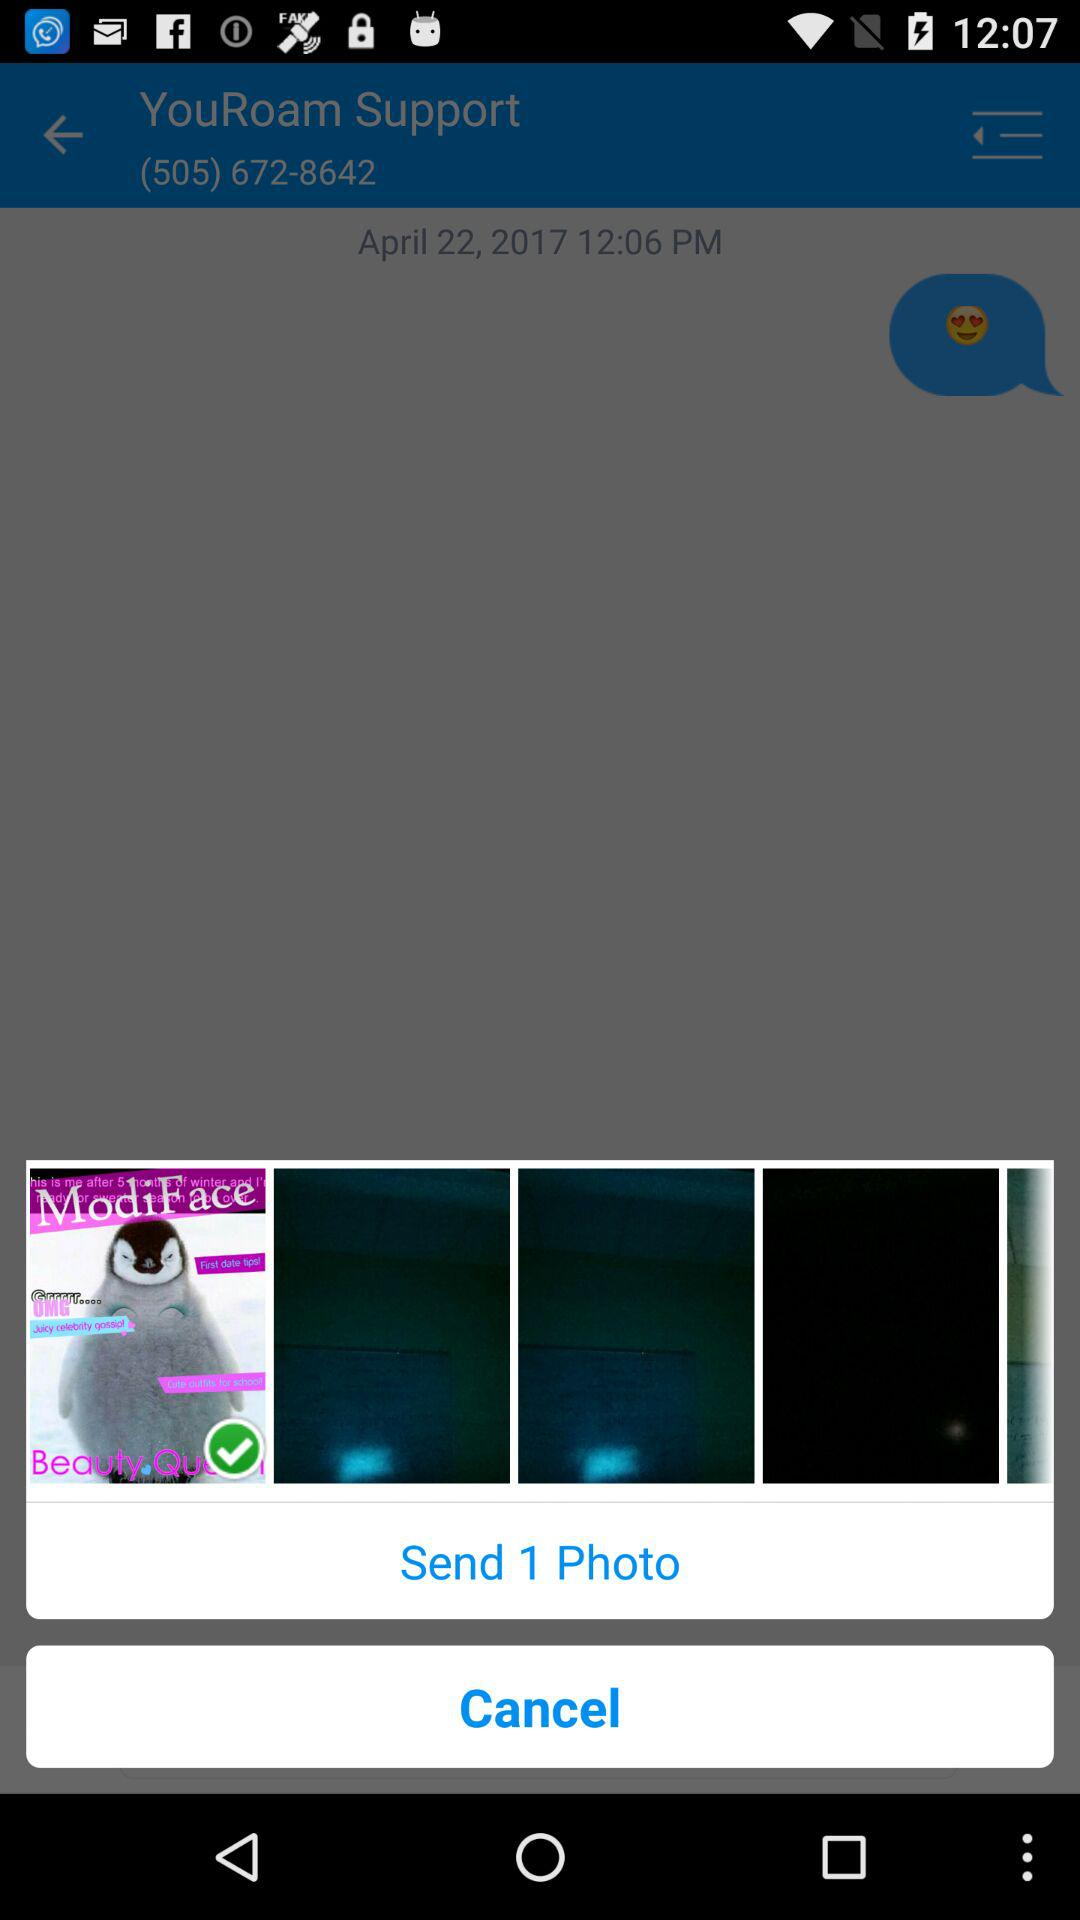What is the phone number? The phone number is (505) 672-8642. 